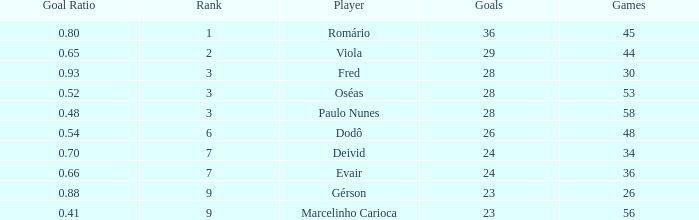How many games have 23 goals with a rank greater than 9? 0.0. 